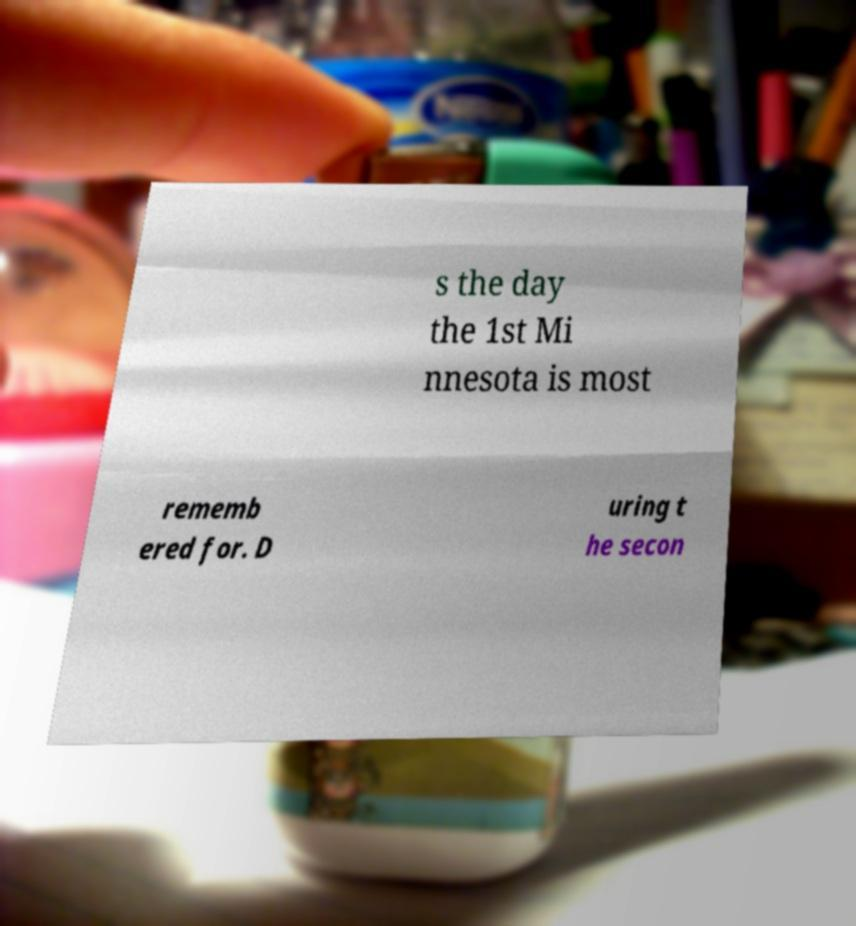I need the written content from this picture converted into text. Can you do that? s the day the 1st Mi nnesota is most rememb ered for. D uring t he secon 